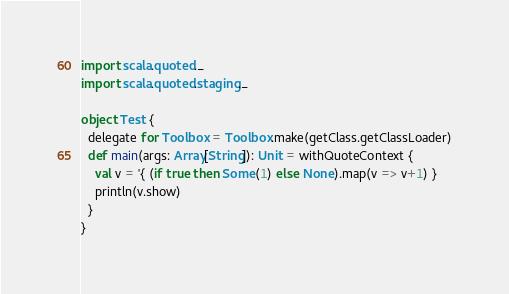Convert code to text. <code><loc_0><loc_0><loc_500><loc_500><_Scala_>import scala.quoted._
import scala.quoted.staging._

object Test {
  delegate for Toolbox = Toolbox.make(getClass.getClassLoader)
  def main(args: Array[String]): Unit = withQuoteContext {
    val v = '{ (if true then Some(1) else None).map(v => v+1) }
    println(v.show)
  }
}
</code> 